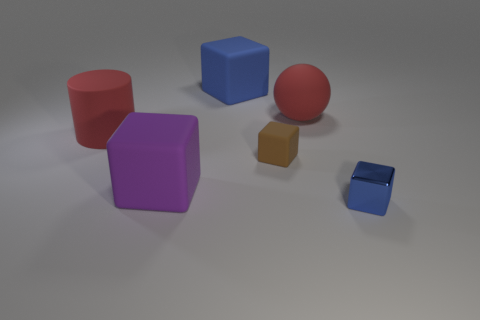What number of objects are either rubber cylinders or big red matte things that are in front of the rubber sphere?
Offer a very short reply. 1. Are there more big green matte cylinders than small matte things?
Provide a short and direct response. No. There is a blue object that is in front of the brown thing; what is its shape?
Your response must be concise. Cube. How many other blue metal things are the same shape as the blue shiny thing?
Make the answer very short. 0. What is the size of the purple rubber block left of the small block that is on the left side of the shiny cube?
Keep it short and to the point. Large. What number of green things are either big rubber objects or spheres?
Provide a short and direct response. 0. Is the number of small brown things that are in front of the brown cube less than the number of small things that are behind the tiny blue block?
Your answer should be very brief. Yes. There is a purple object; is it the same size as the blue block that is in front of the big red cylinder?
Your answer should be compact. No. What number of matte things are the same size as the matte ball?
Give a very brief answer. 3. How many large objects are blue things or blue matte things?
Your answer should be very brief. 1. 